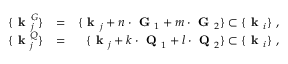<formula> <loc_0><loc_0><loc_500><loc_500>\begin{array} { r l r } { \{ k _ { j } ^ { G } \} } & { = } & { \{ k _ { j } + n \cdot G _ { 1 } + m \cdot G _ { 2 } \} \subset \{ k _ { i } \} , } \\ { \{ k _ { j } ^ { Q } \} } & { = } & { \{ k _ { j } + k \cdot Q _ { 1 } + l \cdot Q _ { 2 } \} \subset \{ k _ { i } \} , } \end{array}</formula> 